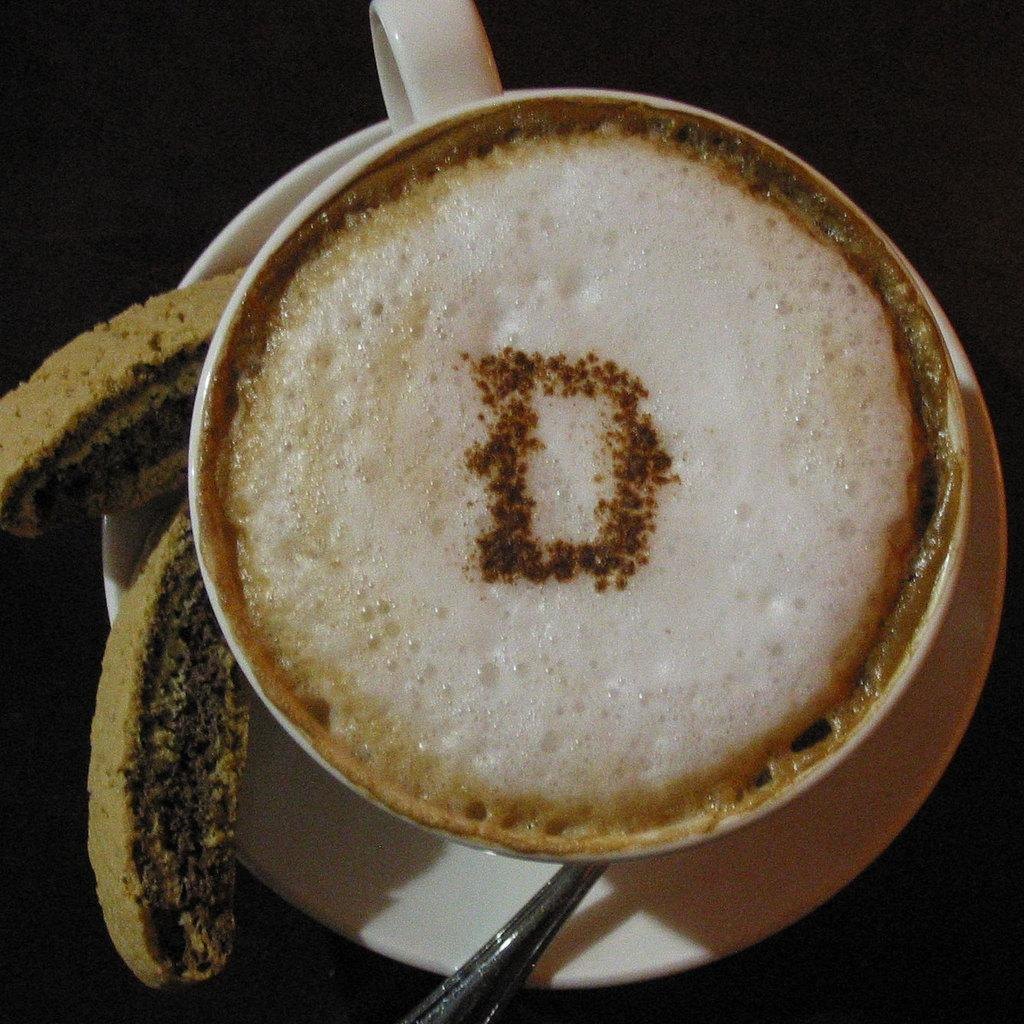What is in the cup that is visible in the image? There is a drink in the cup in the image. Besides the cup, what other items can be seen in the image? There are food items, a spoon, and a saucer visible in the image. What might be used for stirring or scooping the drink or food in the image? The spoon in the image can be used for stirring or scooping. What is the color of the background in the image? The background of the image is dark. What type of peace can be seen in the image? There is no reference to peace in the image; it features a cup with a drink, food items, a spoon, and a saucer. 